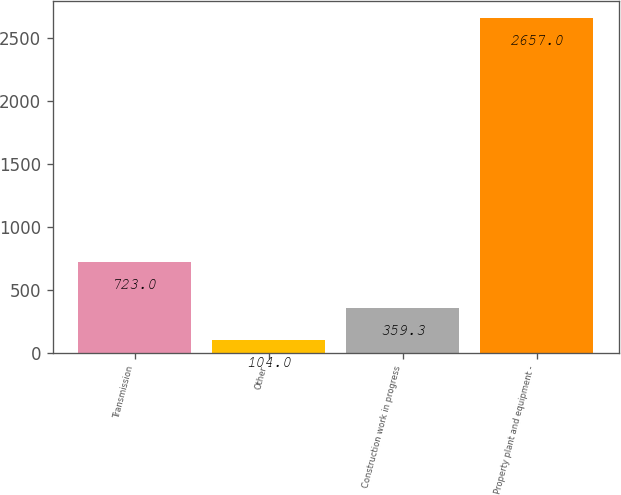Convert chart to OTSL. <chart><loc_0><loc_0><loc_500><loc_500><bar_chart><fcel>Transmission<fcel>Other<fcel>Construction work in progress<fcel>Property plant and equipment -<nl><fcel>723<fcel>104<fcel>359.3<fcel>2657<nl></chart> 